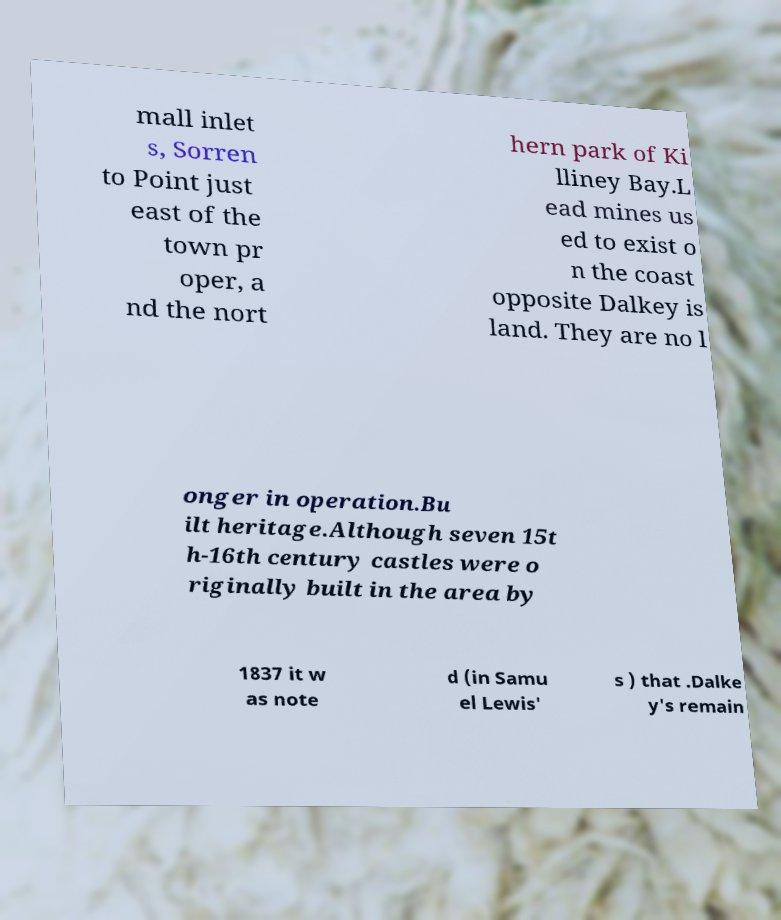For documentation purposes, I need the text within this image transcribed. Could you provide that? mall inlet s, Sorren to Point just east of the town pr oper, a nd the nort hern park of Ki lliney Bay.L ead mines us ed to exist o n the coast opposite Dalkey is land. They are no l onger in operation.Bu ilt heritage.Although seven 15t h-16th century castles were o riginally built in the area by 1837 it w as note d (in Samu el Lewis' s ) that .Dalke y's remain 